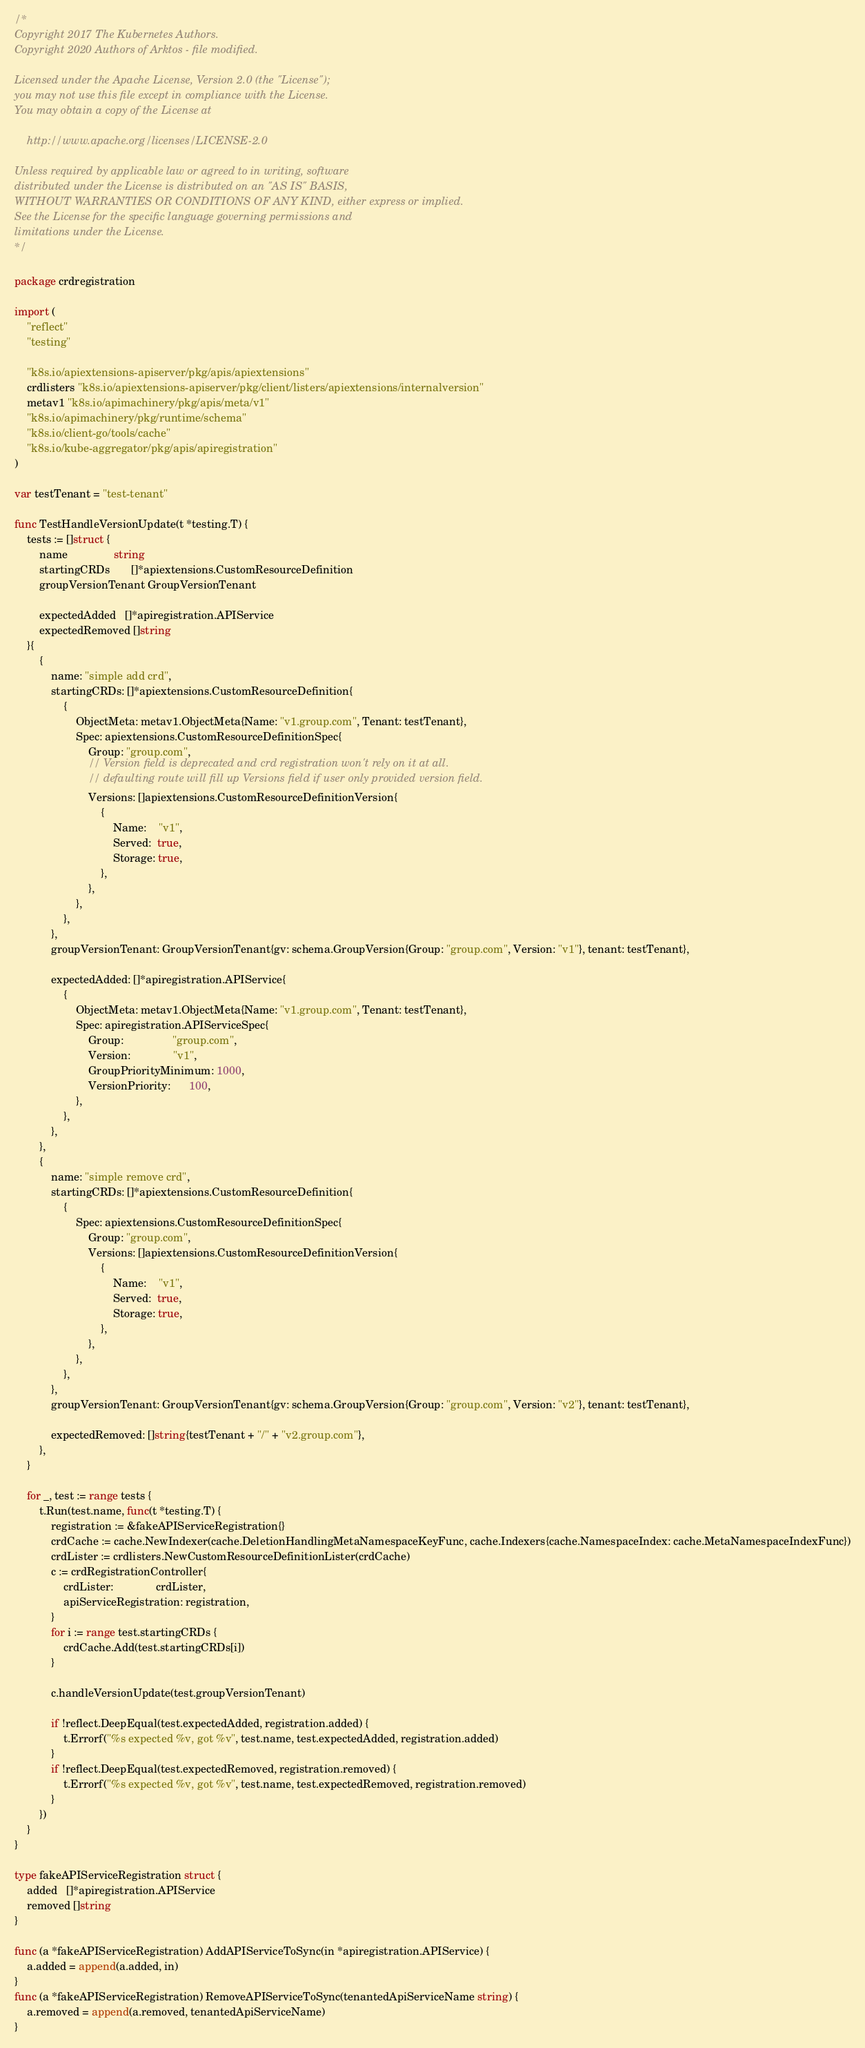Convert code to text. <code><loc_0><loc_0><loc_500><loc_500><_Go_>/*
Copyright 2017 The Kubernetes Authors.
Copyright 2020 Authors of Arktos - file modified.

Licensed under the Apache License, Version 2.0 (the "License");
you may not use this file except in compliance with the License.
You may obtain a copy of the License at

    http://www.apache.org/licenses/LICENSE-2.0

Unless required by applicable law or agreed to in writing, software
distributed under the License is distributed on an "AS IS" BASIS,
WITHOUT WARRANTIES OR CONDITIONS OF ANY KIND, either express or implied.
See the License for the specific language governing permissions and
limitations under the License.
*/

package crdregistration

import (
	"reflect"
	"testing"

	"k8s.io/apiextensions-apiserver/pkg/apis/apiextensions"
	crdlisters "k8s.io/apiextensions-apiserver/pkg/client/listers/apiextensions/internalversion"
	metav1 "k8s.io/apimachinery/pkg/apis/meta/v1"
	"k8s.io/apimachinery/pkg/runtime/schema"
	"k8s.io/client-go/tools/cache"
	"k8s.io/kube-aggregator/pkg/apis/apiregistration"
)

var testTenant = "test-tenant"

func TestHandleVersionUpdate(t *testing.T) {
	tests := []struct {
		name               string
		startingCRDs       []*apiextensions.CustomResourceDefinition
		groupVersionTenant GroupVersionTenant

		expectedAdded   []*apiregistration.APIService
		expectedRemoved []string
	}{
		{
			name: "simple add crd",
			startingCRDs: []*apiextensions.CustomResourceDefinition{
				{
					ObjectMeta: metav1.ObjectMeta{Name: "v1.group.com", Tenant: testTenant},
					Spec: apiextensions.CustomResourceDefinitionSpec{
						Group: "group.com",
						// Version field is deprecated and crd registration won't rely on it at all.
						// defaulting route will fill up Versions field if user only provided version field.
						Versions: []apiextensions.CustomResourceDefinitionVersion{
							{
								Name:    "v1",
								Served:  true,
								Storage: true,
							},
						},
					},
				},
			},
			groupVersionTenant: GroupVersionTenant{gv: schema.GroupVersion{Group: "group.com", Version: "v1"}, tenant: testTenant},

			expectedAdded: []*apiregistration.APIService{
				{
					ObjectMeta: metav1.ObjectMeta{Name: "v1.group.com", Tenant: testTenant},
					Spec: apiregistration.APIServiceSpec{
						Group:                "group.com",
						Version:              "v1",
						GroupPriorityMinimum: 1000,
						VersionPriority:      100,
					},
				},
			},
		},
		{
			name: "simple remove crd",
			startingCRDs: []*apiextensions.CustomResourceDefinition{
				{
					Spec: apiextensions.CustomResourceDefinitionSpec{
						Group: "group.com",
						Versions: []apiextensions.CustomResourceDefinitionVersion{
							{
								Name:    "v1",
								Served:  true,
								Storage: true,
							},
						},
					},
				},
			},
			groupVersionTenant: GroupVersionTenant{gv: schema.GroupVersion{Group: "group.com", Version: "v2"}, tenant: testTenant},

			expectedRemoved: []string{testTenant + "/" + "v2.group.com"},
		},
	}

	for _, test := range tests {
		t.Run(test.name, func(t *testing.T) {
			registration := &fakeAPIServiceRegistration{}
			crdCache := cache.NewIndexer(cache.DeletionHandlingMetaNamespaceKeyFunc, cache.Indexers{cache.NamespaceIndex: cache.MetaNamespaceIndexFunc})
			crdLister := crdlisters.NewCustomResourceDefinitionLister(crdCache)
			c := crdRegistrationController{
				crdLister:              crdLister,
				apiServiceRegistration: registration,
			}
			for i := range test.startingCRDs {
				crdCache.Add(test.startingCRDs[i])
			}

			c.handleVersionUpdate(test.groupVersionTenant)

			if !reflect.DeepEqual(test.expectedAdded, registration.added) {
				t.Errorf("%s expected %v, got %v", test.name, test.expectedAdded, registration.added)
			}
			if !reflect.DeepEqual(test.expectedRemoved, registration.removed) {
				t.Errorf("%s expected %v, got %v", test.name, test.expectedRemoved, registration.removed)
			}
		})
	}
}

type fakeAPIServiceRegistration struct {
	added   []*apiregistration.APIService
	removed []string
}

func (a *fakeAPIServiceRegistration) AddAPIServiceToSync(in *apiregistration.APIService) {
	a.added = append(a.added, in)
}
func (a *fakeAPIServiceRegistration) RemoveAPIServiceToSync(tenantedApiServiceName string) {
	a.removed = append(a.removed, tenantedApiServiceName)
}
</code> 